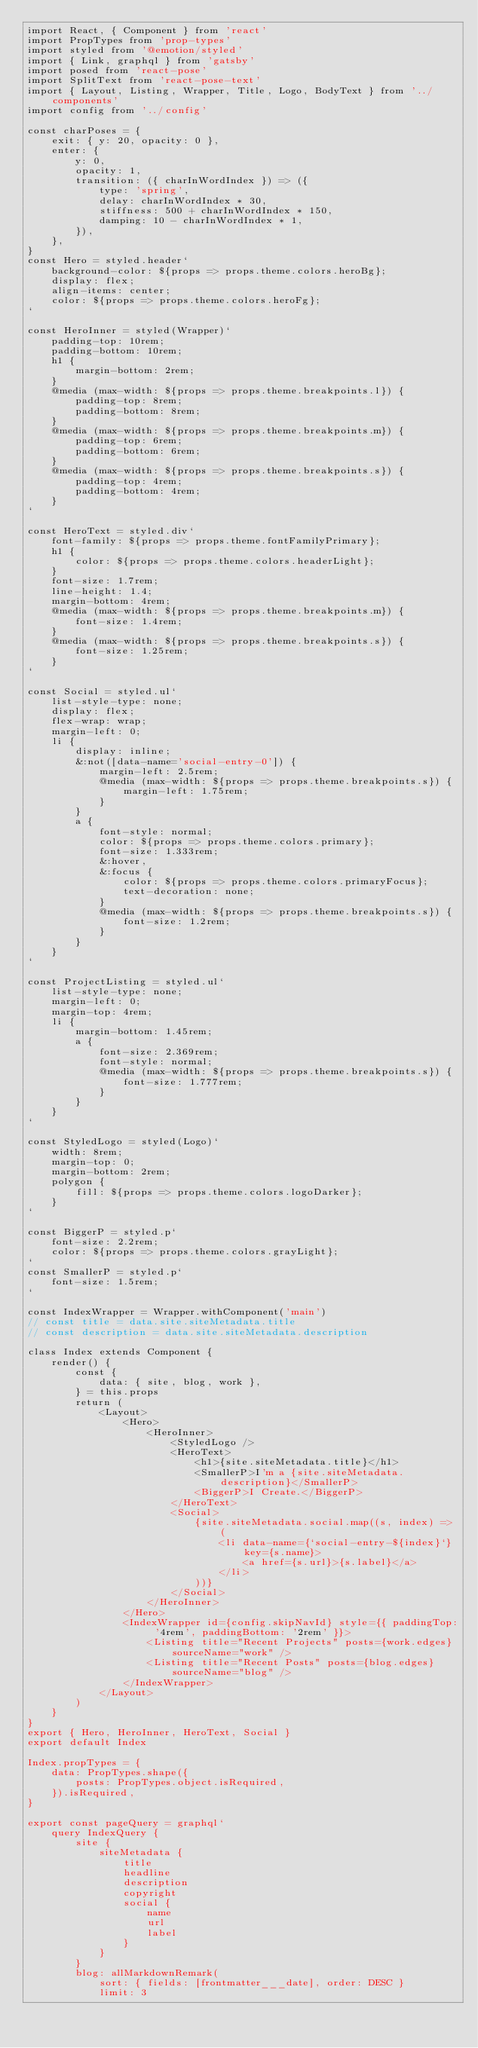Convert code to text. <code><loc_0><loc_0><loc_500><loc_500><_JavaScript_>import React, { Component } from 'react'
import PropTypes from 'prop-types'
import styled from '@emotion/styled'
import { Link, graphql } from 'gatsby'
import posed from 'react-pose'
import SplitText from 'react-pose-text'
import { Layout, Listing, Wrapper, Title, Logo, BodyText } from '../components'
import config from '../config'

const charPoses = {
    exit: { y: 20, opacity: 0 },
    enter: {
        y: 0,
        opacity: 1,
        transition: ({ charInWordIndex }) => ({
            type: 'spring',
            delay: charInWordIndex * 30,
            stiffness: 500 + charInWordIndex * 150,
            damping: 10 - charInWordIndex * 1,
        }),
    },
}
const Hero = styled.header`
    background-color: ${props => props.theme.colors.heroBg};
    display: flex;
    align-items: center;
    color: ${props => props.theme.colors.heroFg};
`

const HeroInner = styled(Wrapper)`
    padding-top: 10rem;
    padding-bottom: 10rem;
    h1 {
        margin-bottom: 2rem;
    }
    @media (max-width: ${props => props.theme.breakpoints.l}) {
        padding-top: 8rem;
        padding-bottom: 8rem;
    }
    @media (max-width: ${props => props.theme.breakpoints.m}) {
        padding-top: 6rem;
        padding-bottom: 6rem;
    }
    @media (max-width: ${props => props.theme.breakpoints.s}) {
        padding-top: 4rem;
        padding-bottom: 4rem;
    }
`

const HeroText = styled.div`
    font-family: ${props => props.theme.fontFamilyPrimary};
    h1 {
        color: ${props => props.theme.colors.headerLight};
    }
    font-size: 1.7rem;
    line-height: 1.4;
    margin-bottom: 4rem;
    @media (max-width: ${props => props.theme.breakpoints.m}) {
        font-size: 1.4rem;
    }
    @media (max-width: ${props => props.theme.breakpoints.s}) {
        font-size: 1.25rem;
    }
`

const Social = styled.ul`
    list-style-type: none;
    display: flex;
    flex-wrap: wrap;
    margin-left: 0;
    li {
        display: inline;
        &:not([data-name='social-entry-0']) {
            margin-left: 2.5rem;
            @media (max-width: ${props => props.theme.breakpoints.s}) {
                margin-left: 1.75rem;
            }
        }
        a {
            font-style: normal;
            color: ${props => props.theme.colors.primary};
            font-size: 1.333rem;
            &:hover,
            &:focus {
                color: ${props => props.theme.colors.primaryFocus};
                text-decoration: none;
            }
            @media (max-width: ${props => props.theme.breakpoints.s}) {
                font-size: 1.2rem;
            }
        }
    }
`

const ProjectListing = styled.ul`
    list-style-type: none;
    margin-left: 0;
    margin-top: 4rem;
    li {
        margin-bottom: 1.45rem;
        a {
            font-size: 2.369rem;
            font-style: normal;
            @media (max-width: ${props => props.theme.breakpoints.s}) {
                font-size: 1.777rem;
            }
        }
    }
`

const StyledLogo = styled(Logo)`
    width: 8rem;
    margin-top: 0;
    margin-bottom: 2rem;
    polygon {
        fill: ${props => props.theme.colors.logoDarker};
    }
`

const BiggerP = styled.p`
    font-size: 2.2rem;
    color: ${props => props.theme.colors.grayLight};
`
const SmallerP = styled.p`
    font-size: 1.5rem;
`

const IndexWrapper = Wrapper.withComponent('main')
// const title = data.site.siteMetadata.title
// const description = data.site.siteMetadata.description

class Index extends Component {
    render() {
        const {
            data: { site, blog, work },
        } = this.props
        return (
            <Layout>
                <Hero>
                    <HeroInner>
                        <StyledLogo />
                        <HeroText>
                            <h1>{site.siteMetadata.title}</h1>
                            <SmallerP>I'm a {site.siteMetadata.description}</SmallerP>
                            <BiggerP>I Create.</BiggerP>
                        </HeroText>
                        <Social>
                            {site.siteMetadata.social.map((s, index) => (
                                <li data-name={`social-entry-${index}`} key={s.name}>
                                    <a href={s.url}>{s.label}</a>
                                </li>
                            ))}
                        </Social>
                    </HeroInner>
                </Hero>
                <IndexWrapper id={config.skipNavId} style={{ paddingTop: '4rem', paddingBottom: '2rem' }}>
                    <Listing title="Recent Projects" posts={work.edges} sourceName="work" />
                    <Listing title="Recent Posts" posts={blog.edges} sourceName="blog" />
                </IndexWrapper>
            </Layout>
        )
    }
}
export { Hero, HeroInner, HeroText, Social }
export default Index

Index.propTypes = {
    data: PropTypes.shape({
        posts: PropTypes.object.isRequired,
    }).isRequired,
}

export const pageQuery = graphql`
    query IndexQuery {
        site {
            siteMetadata {
                title
                headline
                description
                copyright
                social {
                    name
                    url
                    label
                }
            }
        }
        blog: allMarkdownRemark(
            sort: { fields: [frontmatter___date], order: DESC }
            limit: 3</code> 